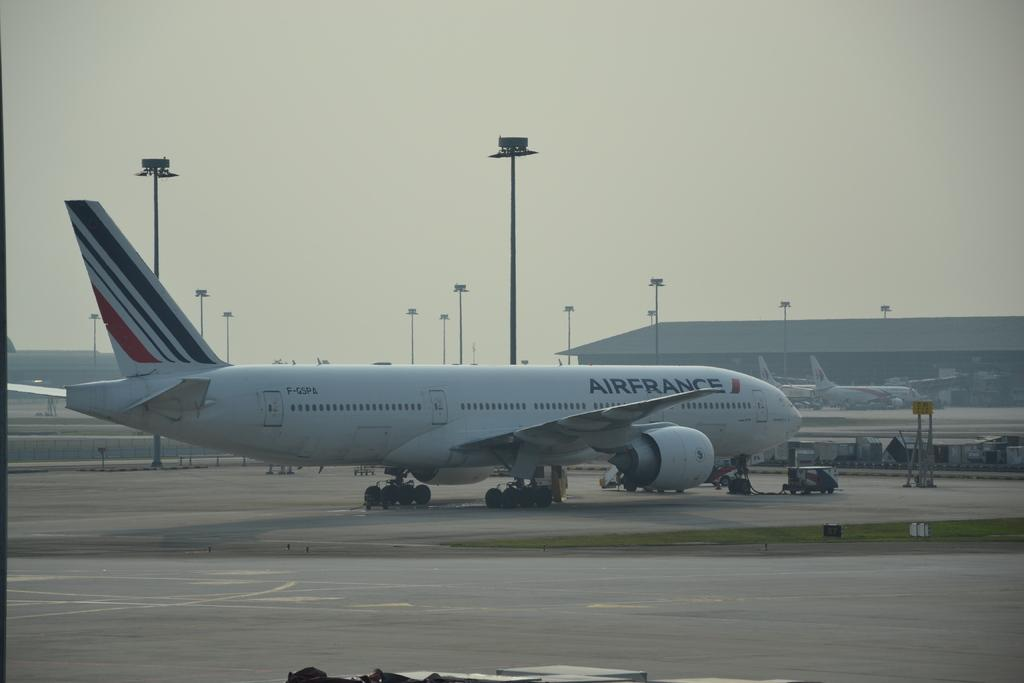What is located on the ground in the image? There are airplanes on the ground in the image. What structures can be seen in the image besides the airplanes? There are poles and a shelter in the image. What is visible in the background of the image? The sky is visible in the background of the image. What is the opinion of the dog in the image about the airplanes? There is no dog present in the image, so it is not possible to determine its opinion about the airplanes. 